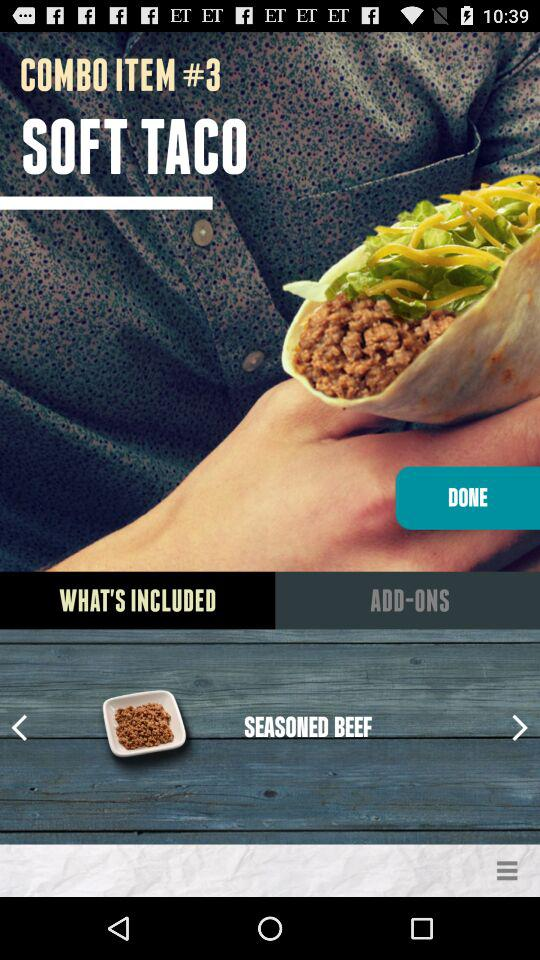What is the name of the recipe? The recipe name is "SOFT TACO". 